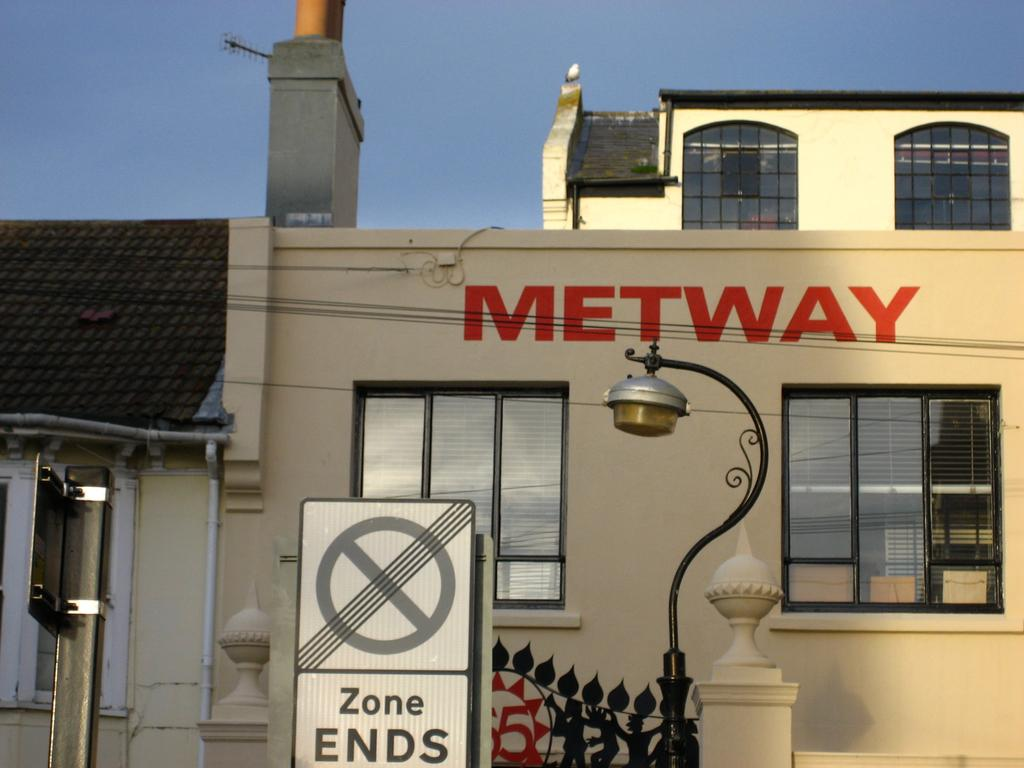What type of structure is present in the image? There is a building in the image. What is attached to the building in the image? There is a hoarding in the image. What other object can be seen in the image? There is a pole in the image. What is the purpose of the light in the image? The light is present in the image. What feature can be observed on the building? The building has windows. What is visible at the top of the image? The sky is visible at the top of the image. Can you tell me how many thumbs are visible in the image? There are no thumbs present in the image. What type of force is being applied to the basketball in the image? There is no basketball present in the image. 